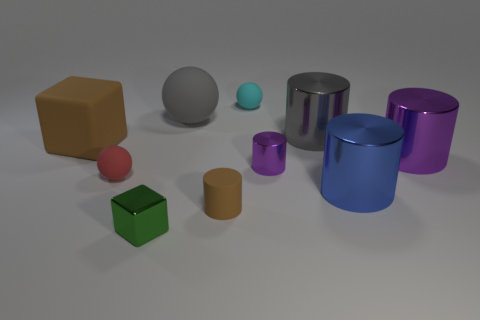Subtract all purple cylinders. How many were subtracted if there are1purple cylinders left? 1 Subtract all gray cylinders. How many cylinders are left? 4 Subtract all tiny metal cylinders. How many cylinders are left? 4 Subtract all yellow cylinders. Subtract all gray blocks. How many cylinders are left? 5 Subtract all balls. How many objects are left? 7 Subtract 1 blue cylinders. How many objects are left? 9 Subtract all large gray metallic objects. Subtract all large gray cylinders. How many objects are left? 8 Add 5 large rubber blocks. How many large rubber blocks are left? 6 Add 6 tiny blue rubber objects. How many tiny blue rubber objects exist? 6 